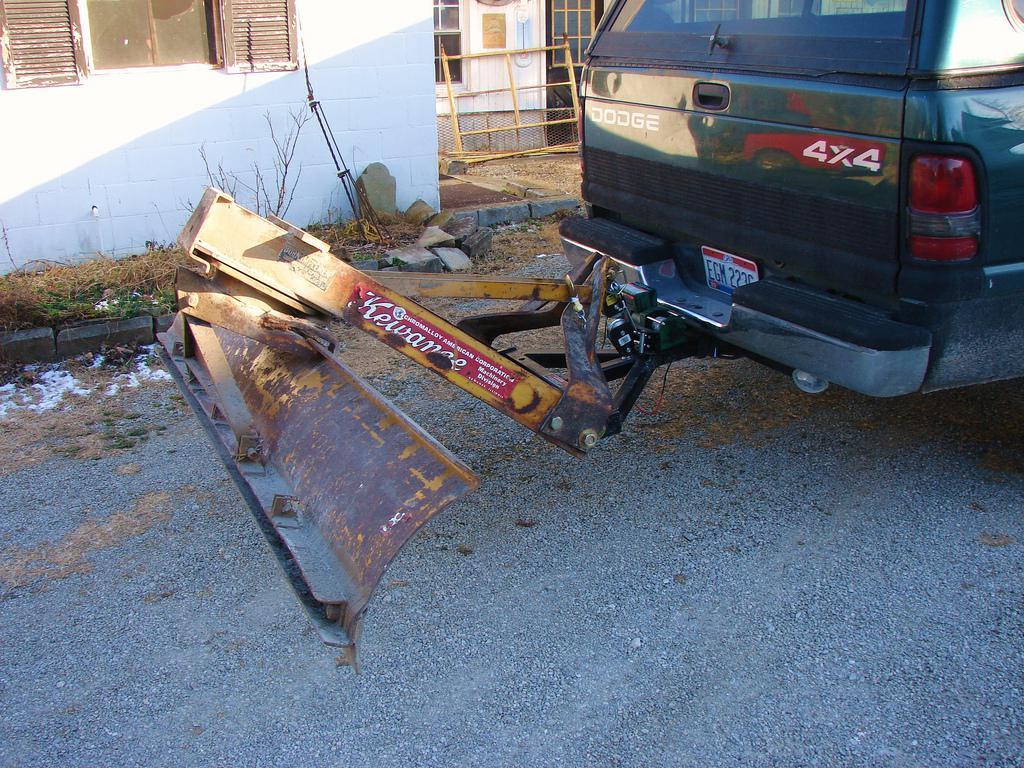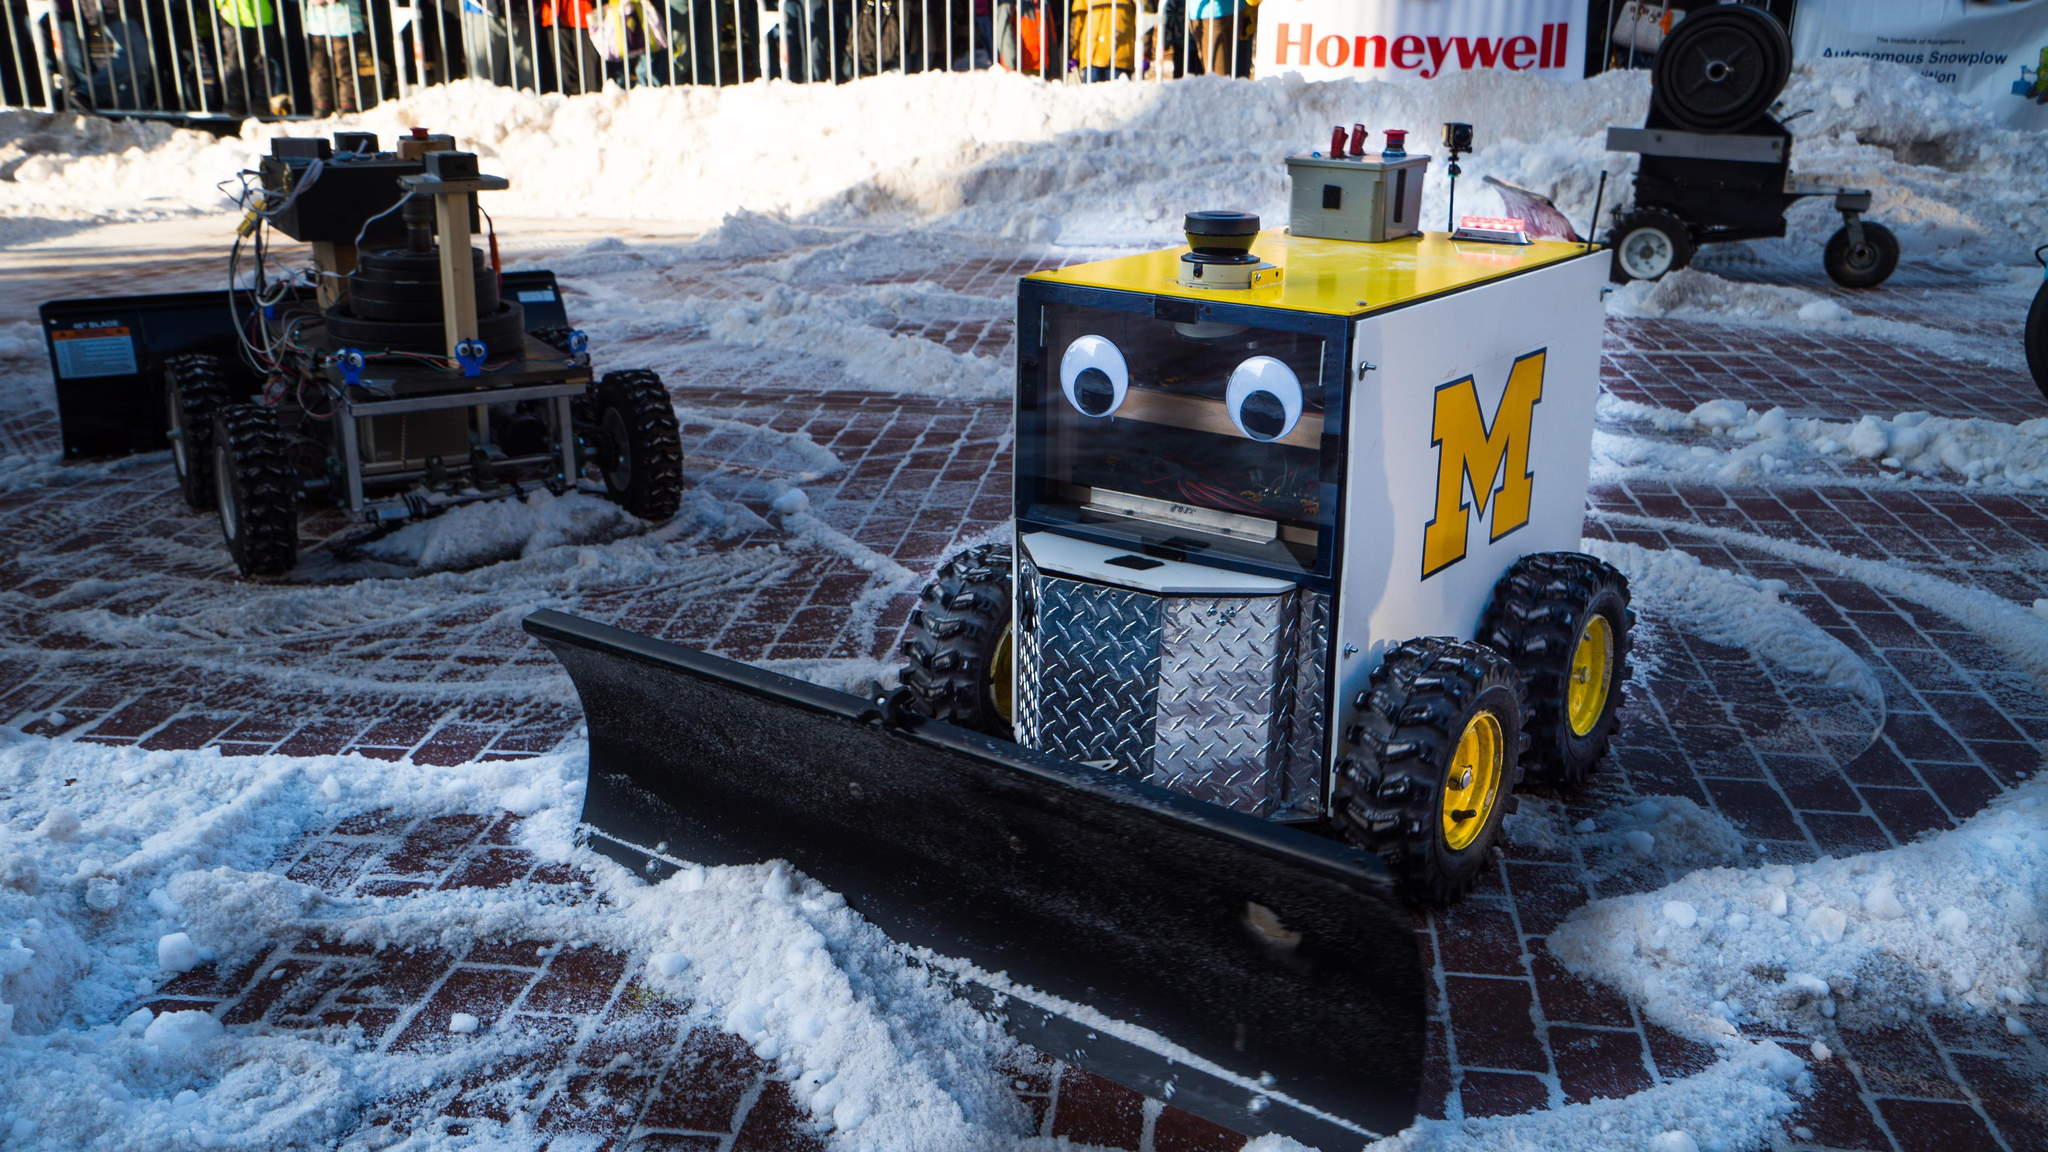The first image is the image on the left, the second image is the image on the right. Considering the images on both sides, is "An image shows a box-shaped machine with a plow, which has no human driver and no truck pulling it." valid? Answer yes or no. Yes. 